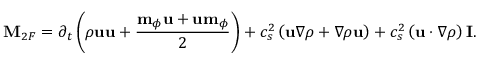<formula> <loc_0><loc_0><loc_500><loc_500>M _ { 2 F } = \partial _ { t } \left ( \rho u u + \frac { m _ { \phi } u + u m _ { \phi } } { 2 } \right ) + c _ { s } ^ { 2 } \left ( u \nabla \rho + \nabla \rho u \right ) + c _ { s } ^ { 2 } \left ( u \cdot \nabla \rho \right ) I .</formula> 